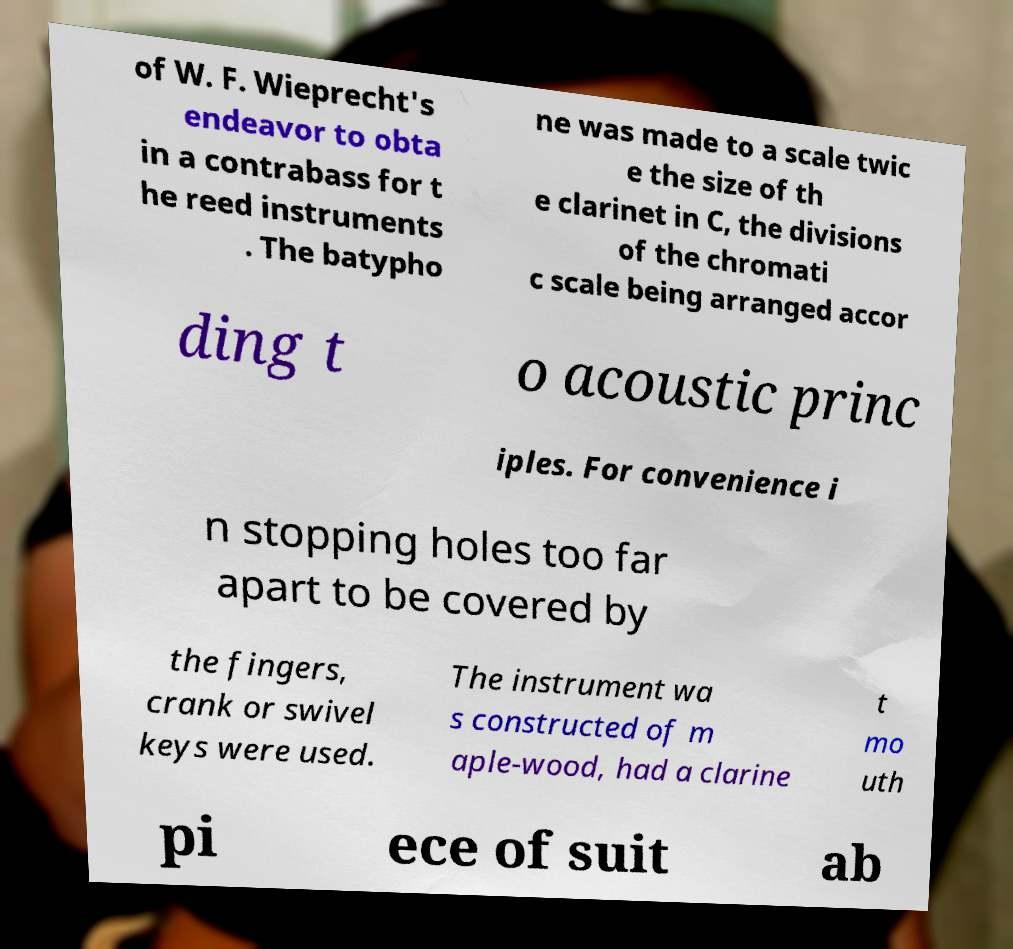For documentation purposes, I need the text within this image transcribed. Could you provide that? of W. F. Wieprecht's endeavor to obta in a contrabass for t he reed instruments . The batypho ne was made to a scale twic e the size of th e clarinet in C, the divisions of the chromati c scale being arranged accor ding t o acoustic princ iples. For convenience i n stopping holes too far apart to be covered by the fingers, crank or swivel keys were used. The instrument wa s constructed of m aple-wood, had a clarine t mo uth pi ece of suit ab 